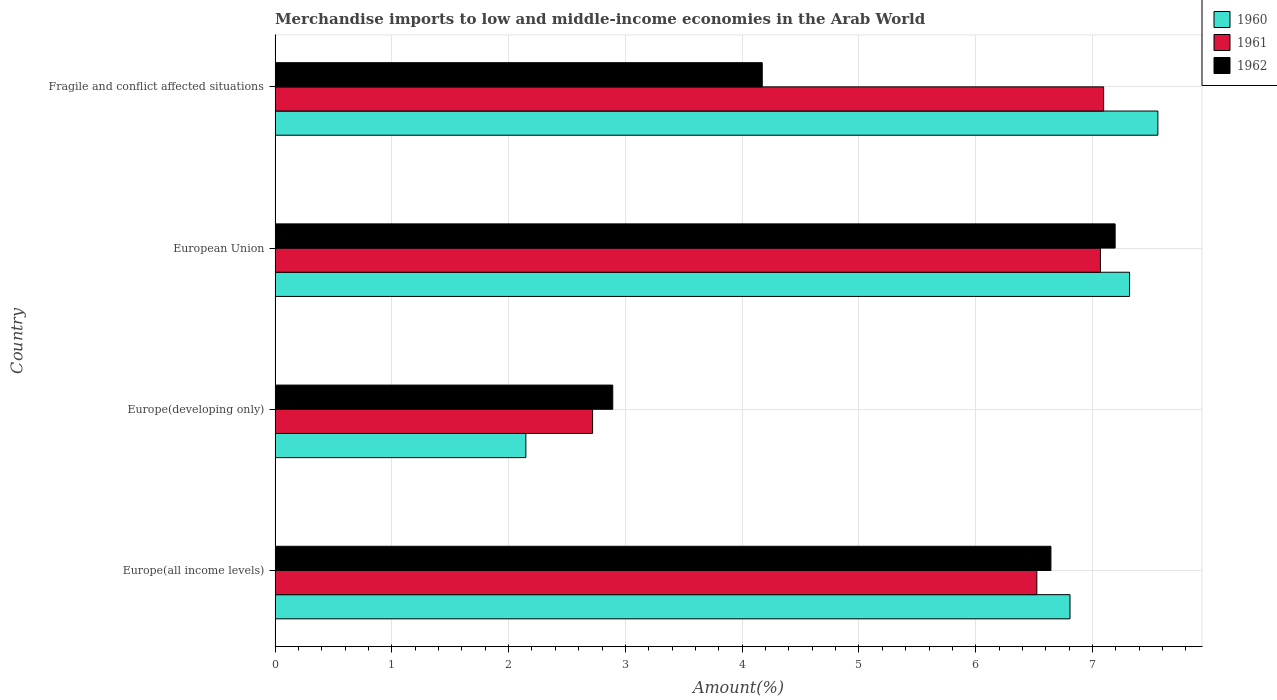How many groups of bars are there?
Your answer should be compact. 4. Are the number of bars on each tick of the Y-axis equal?
Provide a short and direct response. Yes. How many bars are there on the 4th tick from the bottom?
Your answer should be very brief. 3. What is the label of the 1st group of bars from the top?
Offer a terse response. Fragile and conflict affected situations. What is the percentage of amount earned from merchandise imports in 1961 in European Union?
Provide a succinct answer. 7.07. Across all countries, what is the maximum percentage of amount earned from merchandise imports in 1962?
Offer a very short reply. 7.19. Across all countries, what is the minimum percentage of amount earned from merchandise imports in 1960?
Your response must be concise. 2.15. In which country was the percentage of amount earned from merchandise imports in 1960 maximum?
Give a very brief answer. Fragile and conflict affected situations. In which country was the percentage of amount earned from merchandise imports in 1961 minimum?
Offer a very short reply. Europe(developing only). What is the total percentage of amount earned from merchandise imports in 1960 in the graph?
Your answer should be very brief. 23.83. What is the difference between the percentage of amount earned from merchandise imports in 1960 in Europe(developing only) and that in European Union?
Your response must be concise. -5.17. What is the difference between the percentage of amount earned from merchandise imports in 1960 in European Union and the percentage of amount earned from merchandise imports in 1961 in Europe(all income levels)?
Make the answer very short. 0.79. What is the average percentage of amount earned from merchandise imports in 1962 per country?
Offer a terse response. 5.23. What is the difference between the percentage of amount earned from merchandise imports in 1960 and percentage of amount earned from merchandise imports in 1961 in European Union?
Give a very brief answer. 0.25. In how many countries, is the percentage of amount earned from merchandise imports in 1962 greater than 3.2 %?
Give a very brief answer. 3. What is the ratio of the percentage of amount earned from merchandise imports in 1962 in European Union to that in Fragile and conflict affected situations?
Provide a succinct answer. 1.72. Is the percentage of amount earned from merchandise imports in 1962 in Europe(all income levels) less than that in European Union?
Your answer should be compact. Yes. What is the difference between the highest and the second highest percentage of amount earned from merchandise imports in 1961?
Keep it short and to the point. 0.03. What is the difference between the highest and the lowest percentage of amount earned from merchandise imports in 1960?
Your answer should be very brief. 5.41. Is the sum of the percentage of amount earned from merchandise imports in 1962 in Europe(developing only) and European Union greater than the maximum percentage of amount earned from merchandise imports in 1960 across all countries?
Your response must be concise. Yes. What does the 2nd bar from the bottom in Europe(all income levels) represents?
Give a very brief answer. 1961. How many bars are there?
Make the answer very short. 12. Are the values on the major ticks of X-axis written in scientific E-notation?
Your answer should be compact. No. Does the graph contain any zero values?
Offer a very short reply. No. Does the graph contain grids?
Ensure brevity in your answer.  Yes. How many legend labels are there?
Your answer should be very brief. 3. How are the legend labels stacked?
Provide a succinct answer. Vertical. What is the title of the graph?
Make the answer very short. Merchandise imports to low and middle-income economies in the Arab World. What is the label or title of the X-axis?
Offer a terse response. Amount(%). What is the Amount(%) in 1960 in Europe(all income levels)?
Provide a succinct answer. 6.81. What is the Amount(%) in 1961 in Europe(all income levels)?
Keep it short and to the point. 6.52. What is the Amount(%) of 1962 in Europe(all income levels)?
Your answer should be compact. 6.64. What is the Amount(%) of 1960 in Europe(developing only)?
Offer a terse response. 2.15. What is the Amount(%) in 1961 in Europe(developing only)?
Keep it short and to the point. 2.72. What is the Amount(%) of 1962 in Europe(developing only)?
Your response must be concise. 2.89. What is the Amount(%) in 1960 in European Union?
Your answer should be very brief. 7.32. What is the Amount(%) of 1961 in European Union?
Your answer should be very brief. 7.07. What is the Amount(%) in 1962 in European Union?
Provide a succinct answer. 7.19. What is the Amount(%) in 1960 in Fragile and conflict affected situations?
Make the answer very short. 7.56. What is the Amount(%) of 1961 in Fragile and conflict affected situations?
Offer a terse response. 7.1. What is the Amount(%) in 1962 in Fragile and conflict affected situations?
Give a very brief answer. 4.17. Across all countries, what is the maximum Amount(%) in 1960?
Provide a succinct answer. 7.56. Across all countries, what is the maximum Amount(%) of 1961?
Keep it short and to the point. 7.1. Across all countries, what is the maximum Amount(%) of 1962?
Make the answer very short. 7.19. Across all countries, what is the minimum Amount(%) of 1960?
Ensure brevity in your answer.  2.15. Across all countries, what is the minimum Amount(%) in 1961?
Offer a very short reply. 2.72. Across all countries, what is the minimum Amount(%) of 1962?
Your response must be concise. 2.89. What is the total Amount(%) of 1960 in the graph?
Provide a succinct answer. 23.83. What is the total Amount(%) in 1961 in the graph?
Keep it short and to the point. 23.41. What is the total Amount(%) of 1962 in the graph?
Provide a succinct answer. 20.9. What is the difference between the Amount(%) of 1960 in Europe(all income levels) and that in Europe(developing only)?
Your answer should be compact. 4.66. What is the difference between the Amount(%) in 1961 in Europe(all income levels) and that in Europe(developing only)?
Provide a short and direct response. 3.8. What is the difference between the Amount(%) of 1962 in Europe(all income levels) and that in Europe(developing only)?
Make the answer very short. 3.75. What is the difference between the Amount(%) of 1960 in Europe(all income levels) and that in European Union?
Provide a succinct answer. -0.51. What is the difference between the Amount(%) of 1961 in Europe(all income levels) and that in European Union?
Provide a short and direct response. -0.54. What is the difference between the Amount(%) of 1962 in Europe(all income levels) and that in European Union?
Provide a short and direct response. -0.55. What is the difference between the Amount(%) in 1960 in Europe(all income levels) and that in Fragile and conflict affected situations?
Your response must be concise. -0.75. What is the difference between the Amount(%) in 1961 in Europe(all income levels) and that in Fragile and conflict affected situations?
Offer a very short reply. -0.57. What is the difference between the Amount(%) in 1962 in Europe(all income levels) and that in Fragile and conflict affected situations?
Give a very brief answer. 2.47. What is the difference between the Amount(%) of 1960 in Europe(developing only) and that in European Union?
Offer a terse response. -5.17. What is the difference between the Amount(%) in 1961 in Europe(developing only) and that in European Union?
Provide a short and direct response. -4.35. What is the difference between the Amount(%) of 1962 in Europe(developing only) and that in European Union?
Keep it short and to the point. -4.3. What is the difference between the Amount(%) of 1960 in Europe(developing only) and that in Fragile and conflict affected situations?
Provide a succinct answer. -5.41. What is the difference between the Amount(%) in 1961 in Europe(developing only) and that in Fragile and conflict affected situations?
Give a very brief answer. -4.38. What is the difference between the Amount(%) in 1962 in Europe(developing only) and that in Fragile and conflict affected situations?
Make the answer very short. -1.28. What is the difference between the Amount(%) in 1960 in European Union and that in Fragile and conflict affected situations?
Make the answer very short. -0.24. What is the difference between the Amount(%) in 1961 in European Union and that in Fragile and conflict affected situations?
Offer a very short reply. -0.03. What is the difference between the Amount(%) in 1962 in European Union and that in Fragile and conflict affected situations?
Make the answer very short. 3.02. What is the difference between the Amount(%) in 1960 in Europe(all income levels) and the Amount(%) in 1961 in Europe(developing only)?
Offer a terse response. 4.09. What is the difference between the Amount(%) in 1960 in Europe(all income levels) and the Amount(%) in 1962 in Europe(developing only)?
Provide a short and direct response. 3.92. What is the difference between the Amount(%) in 1961 in Europe(all income levels) and the Amount(%) in 1962 in Europe(developing only)?
Your answer should be very brief. 3.63. What is the difference between the Amount(%) in 1960 in Europe(all income levels) and the Amount(%) in 1961 in European Union?
Provide a succinct answer. -0.26. What is the difference between the Amount(%) in 1960 in Europe(all income levels) and the Amount(%) in 1962 in European Union?
Provide a short and direct response. -0.39. What is the difference between the Amount(%) in 1961 in Europe(all income levels) and the Amount(%) in 1962 in European Union?
Your answer should be compact. -0.67. What is the difference between the Amount(%) in 1960 in Europe(all income levels) and the Amount(%) in 1961 in Fragile and conflict affected situations?
Ensure brevity in your answer.  -0.29. What is the difference between the Amount(%) of 1960 in Europe(all income levels) and the Amount(%) of 1962 in Fragile and conflict affected situations?
Your answer should be compact. 2.64. What is the difference between the Amount(%) in 1961 in Europe(all income levels) and the Amount(%) in 1962 in Fragile and conflict affected situations?
Give a very brief answer. 2.35. What is the difference between the Amount(%) in 1960 in Europe(developing only) and the Amount(%) in 1961 in European Union?
Your answer should be very brief. -4.92. What is the difference between the Amount(%) of 1960 in Europe(developing only) and the Amount(%) of 1962 in European Union?
Keep it short and to the point. -5.05. What is the difference between the Amount(%) in 1961 in Europe(developing only) and the Amount(%) in 1962 in European Union?
Your response must be concise. -4.47. What is the difference between the Amount(%) in 1960 in Europe(developing only) and the Amount(%) in 1961 in Fragile and conflict affected situations?
Provide a short and direct response. -4.95. What is the difference between the Amount(%) in 1960 in Europe(developing only) and the Amount(%) in 1962 in Fragile and conflict affected situations?
Your response must be concise. -2.02. What is the difference between the Amount(%) in 1961 in Europe(developing only) and the Amount(%) in 1962 in Fragile and conflict affected situations?
Ensure brevity in your answer.  -1.45. What is the difference between the Amount(%) in 1960 in European Union and the Amount(%) in 1961 in Fragile and conflict affected situations?
Your answer should be very brief. 0.22. What is the difference between the Amount(%) of 1960 in European Union and the Amount(%) of 1962 in Fragile and conflict affected situations?
Offer a terse response. 3.15. What is the difference between the Amount(%) of 1961 in European Union and the Amount(%) of 1962 in Fragile and conflict affected situations?
Ensure brevity in your answer.  2.9. What is the average Amount(%) in 1960 per country?
Make the answer very short. 5.96. What is the average Amount(%) in 1961 per country?
Offer a terse response. 5.85. What is the average Amount(%) of 1962 per country?
Offer a terse response. 5.23. What is the difference between the Amount(%) in 1960 and Amount(%) in 1961 in Europe(all income levels)?
Provide a short and direct response. 0.28. What is the difference between the Amount(%) in 1960 and Amount(%) in 1962 in Europe(all income levels)?
Offer a terse response. 0.16. What is the difference between the Amount(%) in 1961 and Amount(%) in 1962 in Europe(all income levels)?
Keep it short and to the point. -0.12. What is the difference between the Amount(%) in 1960 and Amount(%) in 1961 in Europe(developing only)?
Your response must be concise. -0.57. What is the difference between the Amount(%) of 1960 and Amount(%) of 1962 in Europe(developing only)?
Provide a short and direct response. -0.74. What is the difference between the Amount(%) in 1961 and Amount(%) in 1962 in Europe(developing only)?
Your answer should be very brief. -0.17. What is the difference between the Amount(%) of 1960 and Amount(%) of 1961 in European Union?
Make the answer very short. 0.25. What is the difference between the Amount(%) in 1960 and Amount(%) in 1962 in European Union?
Give a very brief answer. 0.12. What is the difference between the Amount(%) in 1961 and Amount(%) in 1962 in European Union?
Provide a succinct answer. -0.13. What is the difference between the Amount(%) in 1960 and Amount(%) in 1961 in Fragile and conflict affected situations?
Your answer should be compact. 0.46. What is the difference between the Amount(%) in 1960 and Amount(%) in 1962 in Fragile and conflict affected situations?
Your answer should be compact. 3.39. What is the difference between the Amount(%) in 1961 and Amount(%) in 1962 in Fragile and conflict affected situations?
Your answer should be compact. 2.92. What is the ratio of the Amount(%) of 1960 in Europe(all income levels) to that in Europe(developing only)?
Make the answer very short. 3.17. What is the ratio of the Amount(%) in 1961 in Europe(all income levels) to that in Europe(developing only)?
Your answer should be very brief. 2.4. What is the ratio of the Amount(%) in 1962 in Europe(all income levels) to that in Europe(developing only)?
Keep it short and to the point. 2.3. What is the ratio of the Amount(%) in 1960 in Europe(all income levels) to that in European Union?
Offer a terse response. 0.93. What is the ratio of the Amount(%) of 1961 in Europe(all income levels) to that in European Union?
Ensure brevity in your answer.  0.92. What is the ratio of the Amount(%) of 1962 in Europe(all income levels) to that in European Union?
Offer a very short reply. 0.92. What is the ratio of the Amount(%) of 1960 in Europe(all income levels) to that in Fragile and conflict affected situations?
Keep it short and to the point. 0.9. What is the ratio of the Amount(%) of 1961 in Europe(all income levels) to that in Fragile and conflict affected situations?
Provide a succinct answer. 0.92. What is the ratio of the Amount(%) of 1962 in Europe(all income levels) to that in Fragile and conflict affected situations?
Your answer should be compact. 1.59. What is the ratio of the Amount(%) in 1960 in Europe(developing only) to that in European Union?
Offer a terse response. 0.29. What is the ratio of the Amount(%) in 1961 in Europe(developing only) to that in European Union?
Your answer should be compact. 0.38. What is the ratio of the Amount(%) of 1962 in Europe(developing only) to that in European Union?
Make the answer very short. 0.4. What is the ratio of the Amount(%) of 1960 in Europe(developing only) to that in Fragile and conflict affected situations?
Ensure brevity in your answer.  0.28. What is the ratio of the Amount(%) of 1961 in Europe(developing only) to that in Fragile and conflict affected situations?
Ensure brevity in your answer.  0.38. What is the ratio of the Amount(%) of 1962 in Europe(developing only) to that in Fragile and conflict affected situations?
Provide a short and direct response. 0.69. What is the ratio of the Amount(%) of 1962 in European Union to that in Fragile and conflict affected situations?
Offer a terse response. 1.72. What is the difference between the highest and the second highest Amount(%) in 1960?
Give a very brief answer. 0.24. What is the difference between the highest and the second highest Amount(%) of 1961?
Your answer should be compact. 0.03. What is the difference between the highest and the second highest Amount(%) of 1962?
Ensure brevity in your answer.  0.55. What is the difference between the highest and the lowest Amount(%) in 1960?
Your response must be concise. 5.41. What is the difference between the highest and the lowest Amount(%) of 1961?
Ensure brevity in your answer.  4.38. What is the difference between the highest and the lowest Amount(%) in 1962?
Provide a succinct answer. 4.3. 